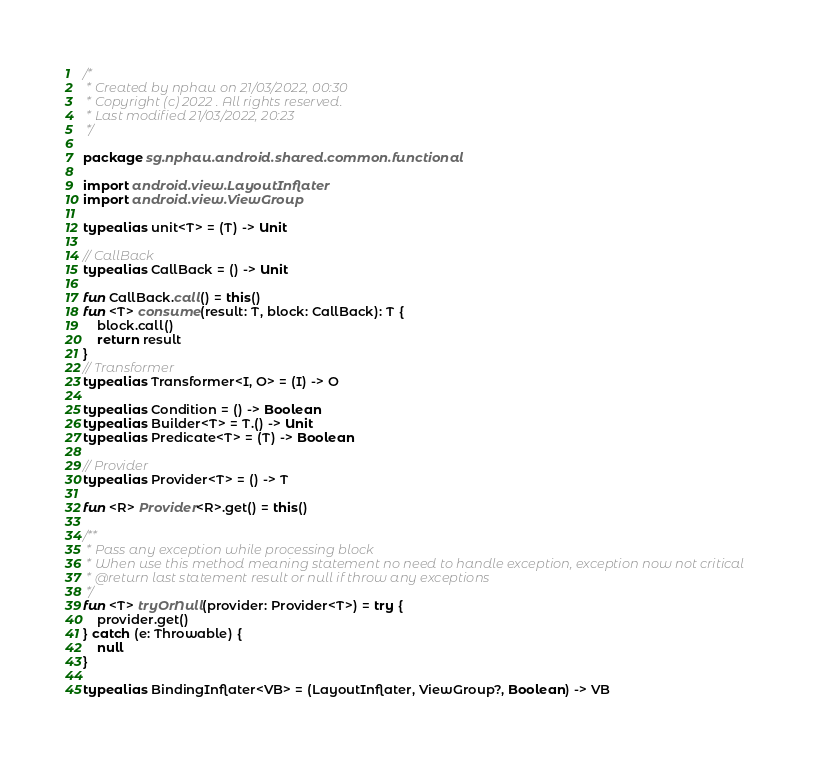<code> <loc_0><loc_0><loc_500><loc_500><_Kotlin_>/*
 * Created by nphau on 21/03/2022, 00:30
 * Copyright (c) 2022 . All rights reserved.
 * Last modified 21/03/2022, 20:23
 */

package sg.nphau.android.shared.common.functional

import android.view.LayoutInflater
import android.view.ViewGroup

typealias unit<T> = (T) -> Unit

// CallBack
typealias CallBack = () -> Unit

fun CallBack.call() = this()
fun <T> consume(result: T, block: CallBack): T {
    block.call()
    return result
}
// Transformer
typealias Transformer<I, O> = (I) -> O

typealias Condition = () -> Boolean
typealias Builder<T> = T.() -> Unit
typealias Predicate<T> = (T) -> Boolean

// Provider
typealias Provider<T> = () -> T

fun <R> Provider<R>.get() = this()

/**
 * Pass any exception while processing block
 * When use this method meaning statement no need to handle exception, exception now not critical
 * @return last statement result or null if throw any exceptions
 */
fun <T> tryOrNull(provider: Provider<T>) = try {
    provider.get()
} catch (e: Throwable) {
    null
}

typealias BindingInflater<VB> = (LayoutInflater, ViewGroup?, Boolean) -> VB</code> 